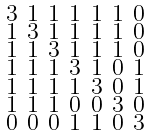<formula> <loc_0><loc_0><loc_500><loc_500>\begin{smallmatrix} 3 & 1 & 1 & 1 & 1 & 1 & 0 \\ 1 & 3 & 1 & 1 & 1 & 1 & 0 \\ 1 & 1 & 3 & 1 & 1 & 1 & 0 \\ 1 & 1 & 1 & 3 & 1 & 0 & 1 \\ 1 & 1 & 1 & 1 & 3 & 0 & 1 \\ 1 & 1 & 1 & 0 & 0 & 3 & 0 \\ 0 & 0 & 0 & 1 & 1 & 0 & 3 \end{smallmatrix}</formula> 